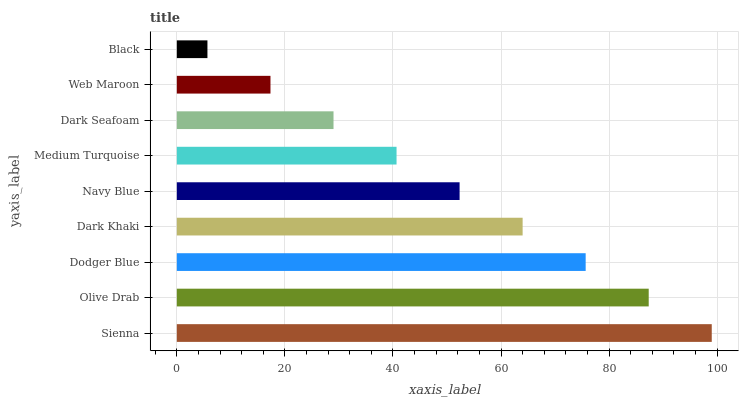Is Black the minimum?
Answer yes or no. Yes. Is Sienna the maximum?
Answer yes or no. Yes. Is Olive Drab the minimum?
Answer yes or no. No. Is Olive Drab the maximum?
Answer yes or no. No. Is Sienna greater than Olive Drab?
Answer yes or no. Yes. Is Olive Drab less than Sienna?
Answer yes or no. Yes. Is Olive Drab greater than Sienna?
Answer yes or no. No. Is Sienna less than Olive Drab?
Answer yes or no. No. Is Navy Blue the high median?
Answer yes or no. Yes. Is Navy Blue the low median?
Answer yes or no. Yes. Is Black the high median?
Answer yes or no. No. Is Sienna the low median?
Answer yes or no. No. 